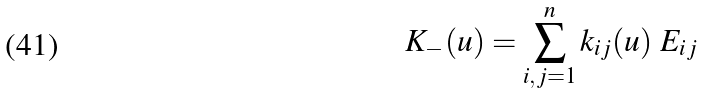Convert formula to latex. <formula><loc_0><loc_0><loc_500><loc_500>K _ { - } ( u ) = \sum _ { i , j = 1 } ^ { n } k _ { i j } ( u ) \ E _ { i j }</formula> 